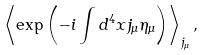Convert formula to latex. <formula><loc_0><loc_0><loc_500><loc_500>\left < \exp \left ( - i \int d ^ { 4 } x j _ { \mu } \eta _ { \mu } \right ) \right > _ { j _ { \mu } } ,</formula> 